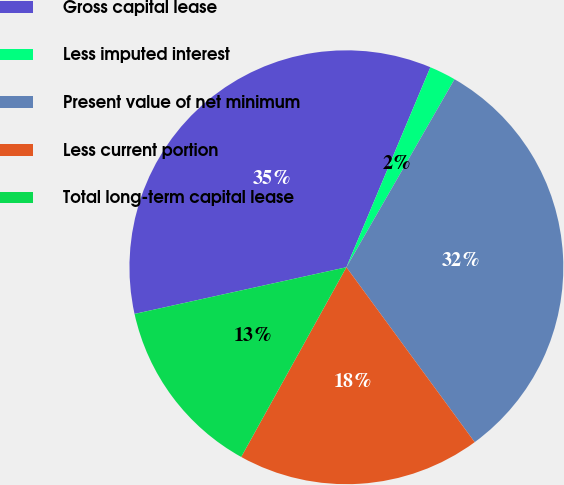Convert chart to OTSL. <chart><loc_0><loc_0><loc_500><loc_500><pie_chart><fcel>Gross capital lease<fcel>Less imputed interest<fcel>Present value of net minimum<fcel>Less current portion<fcel>Total long-term capital lease<nl><fcel>34.78%<fcel>1.98%<fcel>31.62%<fcel>18.13%<fcel>13.49%<nl></chart> 